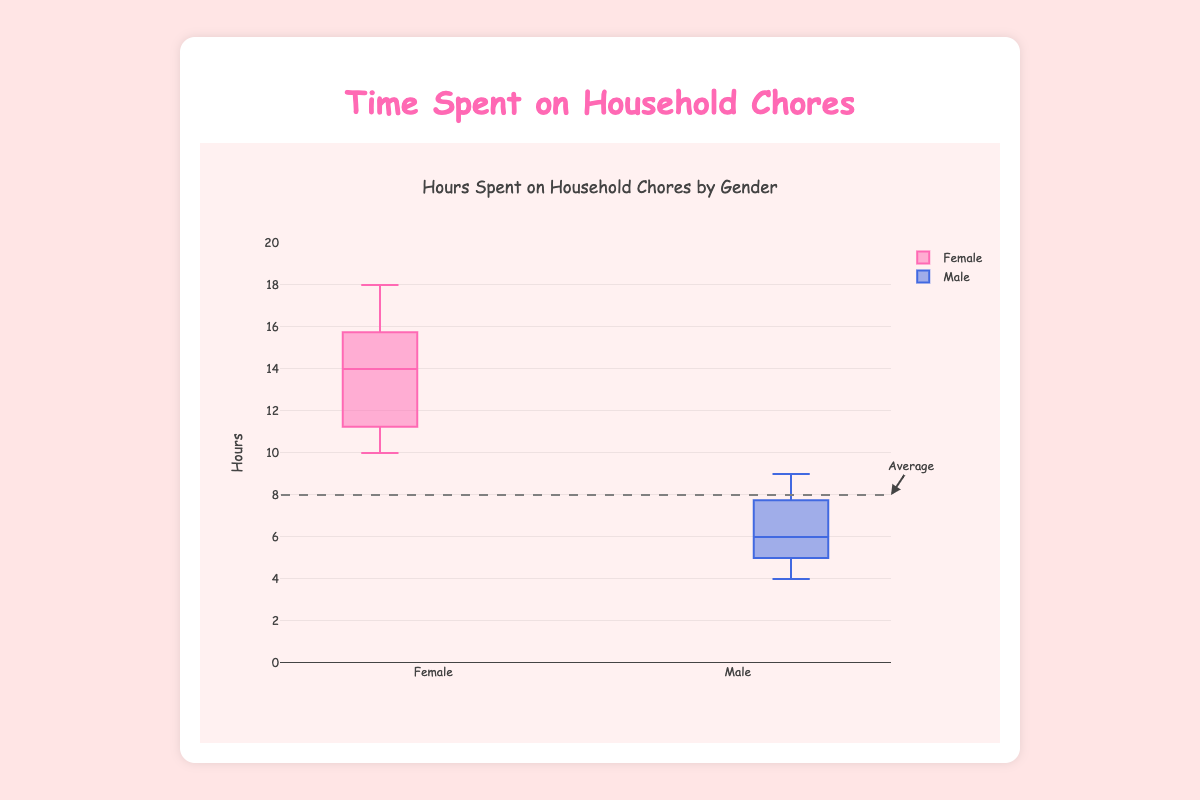What's the title of the chart? The title of the chart is displayed at the top and reads "Hours Spent on Household Chores by Gender".
Answer: Hours Spent on Household Chores by Gender How many data points are used for males in the chart? We can count the number of data points displayed for the male category in the box plot, which is 7.
Answer: 7 What color is used to represent females in the chart? The chart uses pink color (hex code equivalent) to represent females in the box plot.
Answer: Pink What's the lower whisker value for females? The lower whisker value is the smallest value in the box plot for females, which appears to be around 10 hours.
Answer: 10 Which gender has a higher median value for hours spent on household chores? By comparing the median lines inside the boxes, the median value for females is higher than that for males.
Answer: Females What is the median value for males in the chart? The median value for males can be identified by the line inside the male box plot, which is around 6 hours.
Answer: 6 What's the interquartile range (IQR) for females? The IQR is the difference between the third quartile (Q3) and the first quartile (Q1). For females, Q3 appears to be 15 hours, and Q1 seems to be 11 hours, so IQR is 15 - 11 = 4 hours.
Answer: 4 Which gender has a more extensive range of hours? The range is calculated by the difference between the maximum and minimum values. Females have a range of 18 - 10 = 8 hours, while males have a range of 9 - 4 = 5 hours. Females have a more extensive range.
Answer: Females By how many hours does the maximum value for females exceed the maximum value for males? The maximum value for females is 18 hours, and for males, it is 9 hours. The excess is 18 - 9 = 9 hours.
Answer: 9 hours What does the dashed horizontal line in the plot indicate? The dashed horizontal line is at 8 hours, and it is accompanied by an annotation pointing to it, indicating it represents the average hours spent on household chores.
Answer: Average hours spent on household chores 